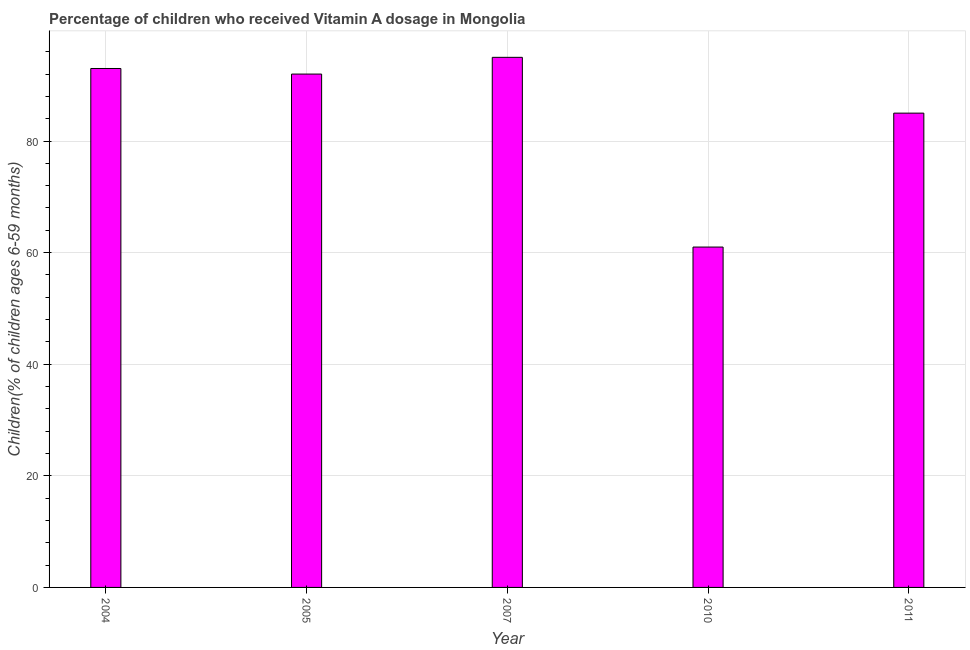Does the graph contain any zero values?
Your answer should be compact. No. Does the graph contain grids?
Provide a succinct answer. Yes. What is the title of the graph?
Your answer should be very brief. Percentage of children who received Vitamin A dosage in Mongolia. What is the label or title of the X-axis?
Your response must be concise. Year. What is the label or title of the Y-axis?
Ensure brevity in your answer.  Children(% of children ages 6-59 months). What is the vitamin a supplementation coverage rate in 2010?
Provide a short and direct response. 61. Across all years, what is the maximum vitamin a supplementation coverage rate?
Offer a terse response. 95. In which year was the vitamin a supplementation coverage rate minimum?
Provide a succinct answer. 2010. What is the sum of the vitamin a supplementation coverage rate?
Your response must be concise. 426. What is the average vitamin a supplementation coverage rate per year?
Your response must be concise. 85. What is the median vitamin a supplementation coverage rate?
Keep it short and to the point. 92. In how many years, is the vitamin a supplementation coverage rate greater than 60 %?
Your answer should be compact. 5. What is the ratio of the vitamin a supplementation coverage rate in 2010 to that in 2011?
Give a very brief answer. 0.72. Is the vitamin a supplementation coverage rate in 2005 less than that in 2011?
Your response must be concise. No. Is the difference between the vitamin a supplementation coverage rate in 2007 and 2010 greater than the difference between any two years?
Offer a very short reply. Yes. What is the difference between the highest and the lowest vitamin a supplementation coverage rate?
Your answer should be compact. 34. In how many years, is the vitamin a supplementation coverage rate greater than the average vitamin a supplementation coverage rate taken over all years?
Make the answer very short. 3. How many bars are there?
Provide a succinct answer. 5. Are all the bars in the graph horizontal?
Make the answer very short. No. How many years are there in the graph?
Make the answer very short. 5. What is the difference between two consecutive major ticks on the Y-axis?
Provide a short and direct response. 20. What is the Children(% of children ages 6-59 months) of 2004?
Your answer should be very brief. 93. What is the Children(% of children ages 6-59 months) of 2005?
Your answer should be very brief. 92. What is the Children(% of children ages 6-59 months) of 2007?
Provide a short and direct response. 95. What is the difference between the Children(% of children ages 6-59 months) in 2005 and 2007?
Keep it short and to the point. -3. What is the difference between the Children(% of children ages 6-59 months) in 2007 and 2010?
Your response must be concise. 34. What is the ratio of the Children(% of children ages 6-59 months) in 2004 to that in 2007?
Provide a succinct answer. 0.98. What is the ratio of the Children(% of children ages 6-59 months) in 2004 to that in 2010?
Offer a terse response. 1.52. What is the ratio of the Children(% of children ages 6-59 months) in 2004 to that in 2011?
Make the answer very short. 1.09. What is the ratio of the Children(% of children ages 6-59 months) in 2005 to that in 2010?
Offer a very short reply. 1.51. What is the ratio of the Children(% of children ages 6-59 months) in 2005 to that in 2011?
Make the answer very short. 1.08. What is the ratio of the Children(% of children ages 6-59 months) in 2007 to that in 2010?
Your answer should be very brief. 1.56. What is the ratio of the Children(% of children ages 6-59 months) in 2007 to that in 2011?
Provide a short and direct response. 1.12. What is the ratio of the Children(% of children ages 6-59 months) in 2010 to that in 2011?
Your answer should be very brief. 0.72. 